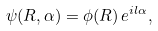<formula> <loc_0><loc_0><loc_500><loc_500>\psi ( R , \alpha ) = \phi ( R ) \, e ^ { i l \alpha } ,</formula> 